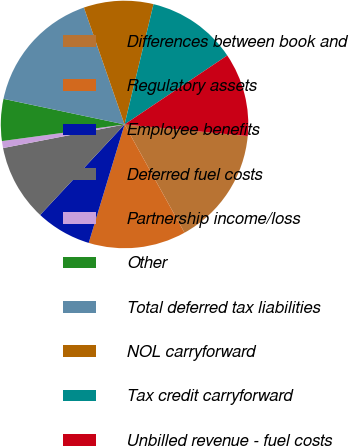<chart> <loc_0><loc_0><loc_500><loc_500><pie_chart><fcel>Differences between book and<fcel>Regulatory assets<fcel>Employee benefits<fcel>Deferred fuel costs<fcel>Partnership income/loss<fcel>Other<fcel>Total deferred tax liabilities<fcel>NOL carryforward<fcel>Tax credit carryforward<fcel>Unbilled revenue - fuel costs<nl><fcel>15.45%<fcel>12.73%<fcel>7.27%<fcel>10.0%<fcel>0.91%<fcel>5.46%<fcel>16.36%<fcel>9.09%<fcel>11.82%<fcel>10.91%<nl></chart> 